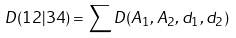Convert formula to latex. <formula><loc_0><loc_0><loc_500><loc_500>D ( 1 2 | 3 4 ) = \sum D ( A _ { 1 } , A _ { 2 } , d _ { 1 } , d _ { 2 } )</formula> 